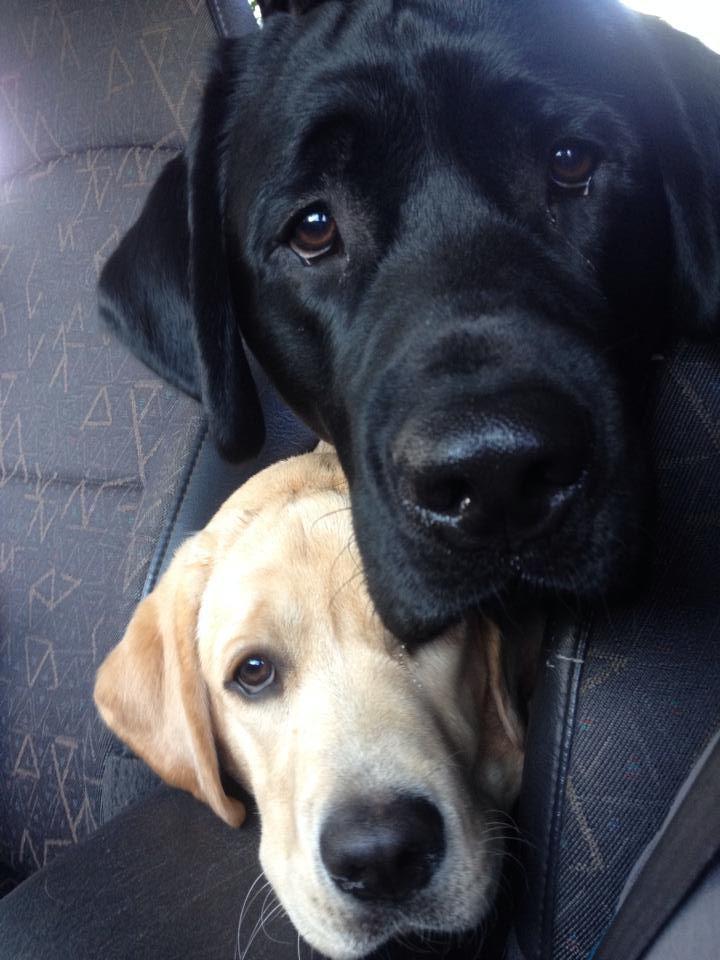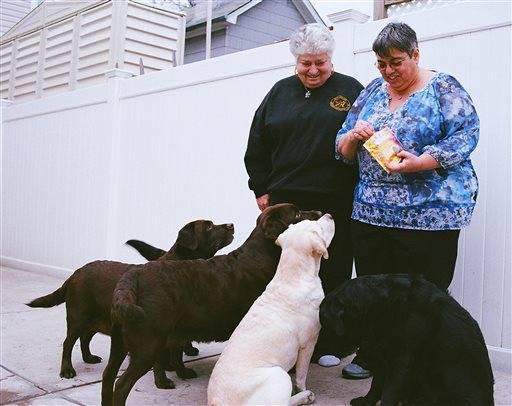The first image is the image on the left, the second image is the image on the right. Given the left and right images, does the statement "One dog is wearing a collar and sitting." hold true? Answer yes or no. No. The first image is the image on the left, the second image is the image on the right. Examine the images to the left and right. Is the description "Only black labrador retrievers are shown, and one dog is in a reclining pose on something soft, and at least one dog wears a collar." accurate? Answer yes or no. No. 